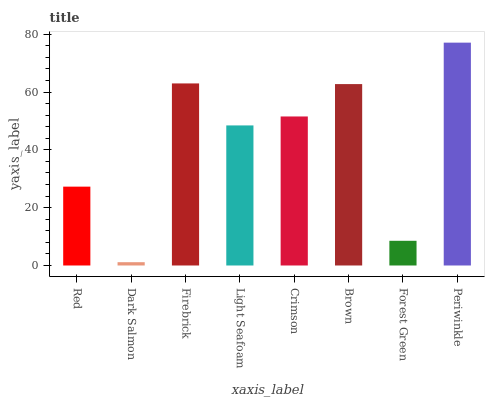Is Firebrick the minimum?
Answer yes or no. No. Is Firebrick the maximum?
Answer yes or no. No. Is Firebrick greater than Dark Salmon?
Answer yes or no. Yes. Is Dark Salmon less than Firebrick?
Answer yes or no. Yes. Is Dark Salmon greater than Firebrick?
Answer yes or no. No. Is Firebrick less than Dark Salmon?
Answer yes or no. No. Is Crimson the high median?
Answer yes or no. Yes. Is Light Seafoam the low median?
Answer yes or no. Yes. Is Light Seafoam the high median?
Answer yes or no. No. Is Brown the low median?
Answer yes or no. No. 